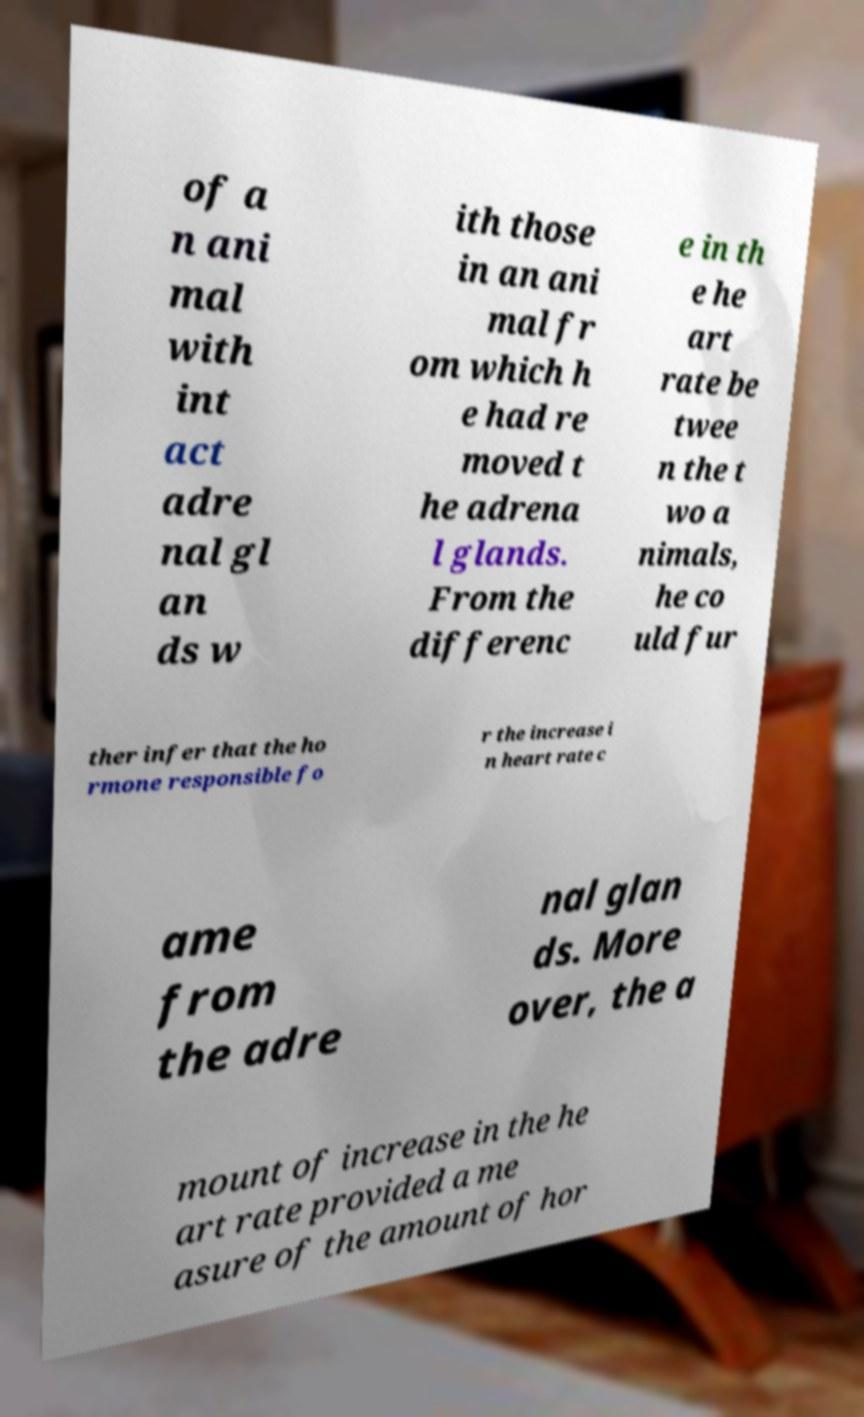Can you read and provide the text displayed in the image?This photo seems to have some interesting text. Can you extract and type it out for me? of a n ani mal with int act adre nal gl an ds w ith those in an ani mal fr om which h e had re moved t he adrena l glands. From the differenc e in th e he art rate be twee n the t wo a nimals, he co uld fur ther infer that the ho rmone responsible fo r the increase i n heart rate c ame from the adre nal glan ds. More over, the a mount of increase in the he art rate provided a me asure of the amount of hor 